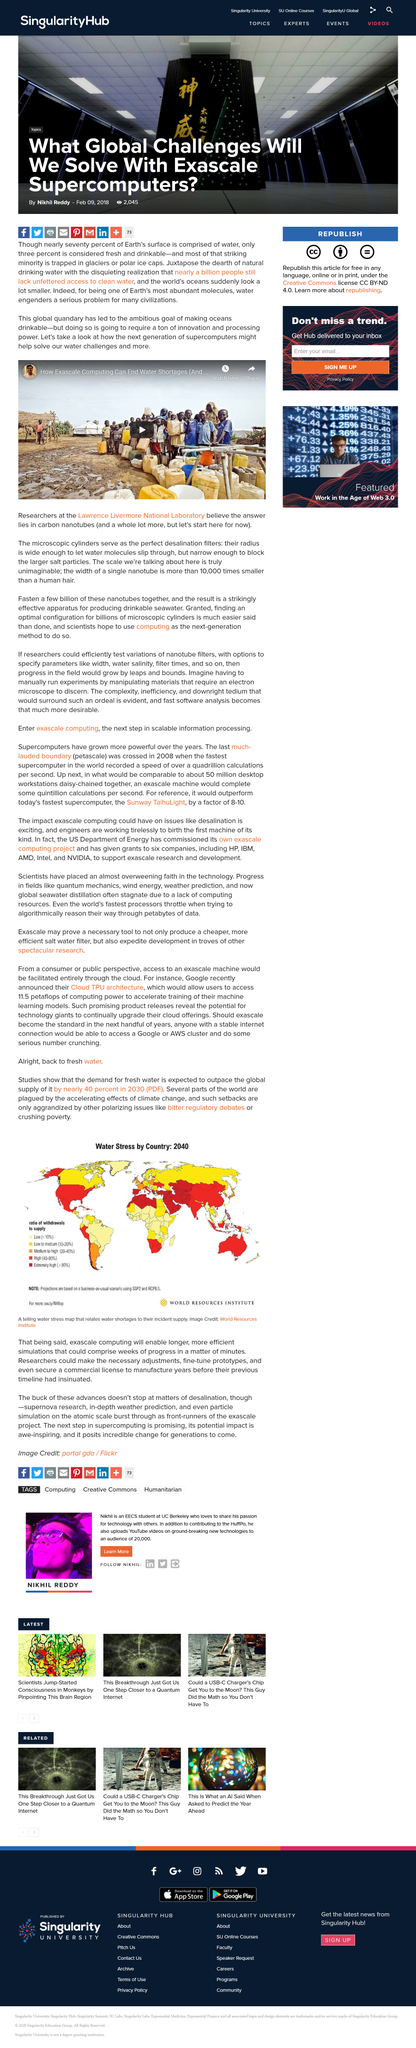Point out several critical features in this image. The radius of a carbon nanotube is sufficiently wide to permit the passage of water molecules. The width of a single carbon nanotube is 10,000 times smaller than a human hair. The Lawrence Livermore National Laboratory's researchers propose that the solution to the problem lies in carbon nanotubes. 